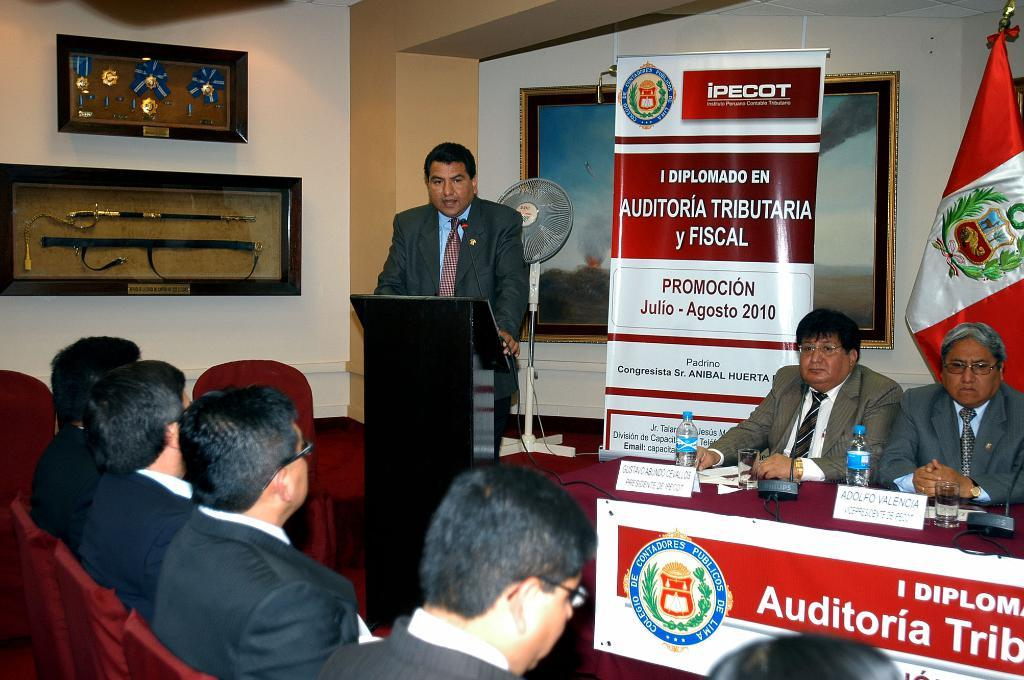What are the people in the image doing? The people in the image are sitting on chairs. What objects can be seen in the image besides the chairs? There are bottles, boards, a fan, a flag, hoardings, and frames on the wall in the image. What type of pest can be seen crawling on the flag in the image? There are no pests visible in the image, and the flag is not mentioned as having any pests on it. 